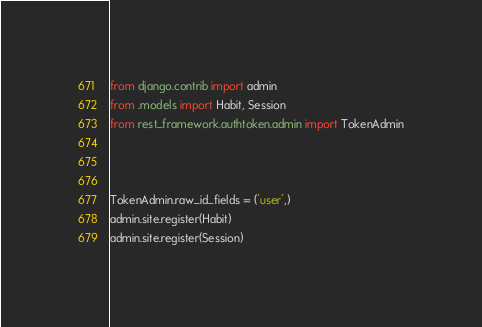<code> <loc_0><loc_0><loc_500><loc_500><_Python_>from django.contrib import admin
from .models import Habit, Session
from rest_framework.authtoken.admin import TokenAdmin



TokenAdmin.raw_id_fields = ('user',)
admin.site.register(Habit)
admin.site.register(Session)</code> 